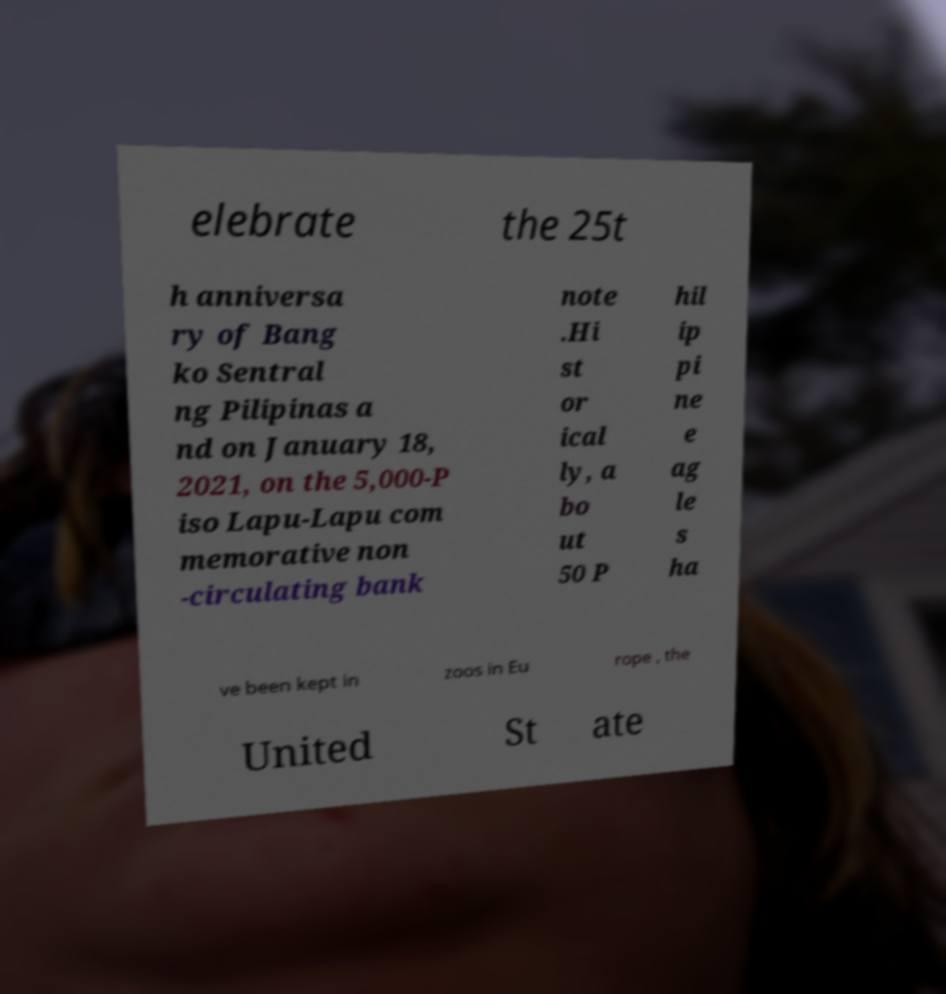Could you extract and type out the text from this image? elebrate the 25t h anniversa ry of Bang ko Sentral ng Pilipinas a nd on January 18, 2021, on the 5,000-P iso Lapu-Lapu com memorative non -circulating bank note .Hi st or ical ly, a bo ut 50 P hil ip pi ne e ag le s ha ve been kept in zoos in Eu rope , the United St ate 